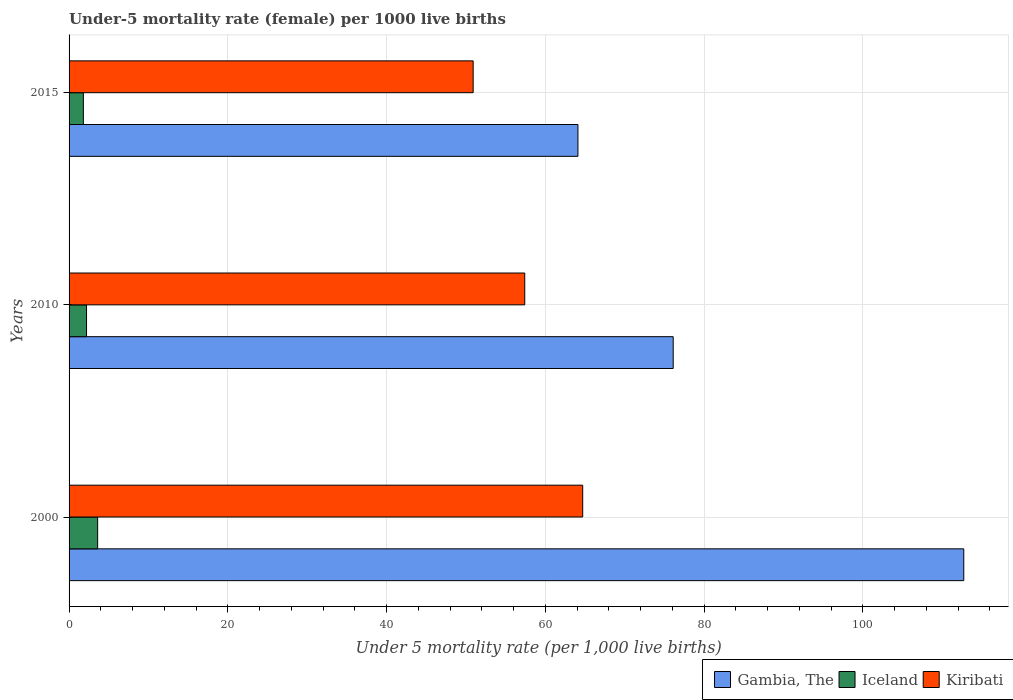How many different coloured bars are there?
Your response must be concise. 3. How many groups of bars are there?
Provide a short and direct response. 3. Are the number of bars on each tick of the Y-axis equal?
Ensure brevity in your answer.  Yes. How many bars are there on the 2nd tick from the top?
Offer a terse response. 3. In how many cases, is the number of bars for a given year not equal to the number of legend labels?
Keep it short and to the point. 0. What is the under-five mortality rate in Iceland in 2000?
Keep it short and to the point. 3.6. Across all years, what is the maximum under-five mortality rate in Kiribati?
Give a very brief answer. 64.7. Across all years, what is the minimum under-five mortality rate in Kiribati?
Provide a short and direct response. 50.9. In which year was the under-five mortality rate in Iceland minimum?
Your answer should be compact. 2015. What is the total under-five mortality rate in Gambia, The in the graph?
Provide a succinct answer. 252.9. What is the difference between the under-five mortality rate in Iceland in 2010 and the under-five mortality rate in Kiribati in 2000?
Provide a succinct answer. -62.5. What is the average under-five mortality rate in Gambia, The per year?
Make the answer very short. 84.3. In the year 2010, what is the difference between the under-five mortality rate in Iceland and under-five mortality rate in Kiribati?
Ensure brevity in your answer.  -55.2. What is the ratio of the under-five mortality rate in Kiribati in 2010 to that in 2015?
Offer a terse response. 1.13. What is the difference between the highest and the lowest under-five mortality rate in Iceland?
Give a very brief answer. 1.8. In how many years, is the under-five mortality rate in Iceland greater than the average under-five mortality rate in Iceland taken over all years?
Offer a terse response. 1. Is the sum of the under-five mortality rate in Kiribati in 2000 and 2010 greater than the maximum under-five mortality rate in Gambia, The across all years?
Ensure brevity in your answer.  Yes. What does the 2nd bar from the top in 2010 represents?
Provide a succinct answer. Iceland. What does the 3rd bar from the bottom in 2015 represents?
Provide a succinct answer. Kiribati. Are all the bars in the graph horizontal?
Give a very brief answer. Yes. Are the values on the major ticks of X-axis written in scientific E-notation?
Ensure brevity in your answer.  No. Does the graph contain any zero values?
Provide a short and direct response. No. Does the graph contain grids?
Provide a succinct answer. Yes. Where does the legend appear in the graph?
Make the answer very short. Bottom right. What is the title of the graph?
Your answer should be very brief. Under-5 mortality rate (female) per 1000 live births. What is the label or title of the X-axis?
Your answer should be compact. Under 5 mortality rate (per 1,0 live births). What is the Under 5 mortality rate (per 1,000 live births) of Gambia, The in 2000?
Ensure brevity in your answer.  112.7. What is the Under 5 mortality rate (per 1,000 live births) in Iceland in 2000?
Make the answer very short. 3.6. What is the Under 5 mortality rate (per 1,000 live births) in Kiribati in 2000?
Keep it short and to the point. 64.7. What is the Under 5 mortality rate (per 1,000 live births) in Gambia, The in 2010?
Keep it short and to the point. 76.1. What is the Under 5 mortality rate (per 1,000 live births) of Iceland in 2010?
Your answer should be compact. 2.2. What is the Under 5 mortality rate (per 1,000 live births) of Kiribati in 2010?
Make the answer very short. 57.4. What is the Under 5 mortality rate (per 1,000 live births) of Gambia, The in 2015?
Make the answer very short. 64.1. What is the Under 5 mortality rate (per 1,000 live births) in Iceland in 2015?
Make the answer very short. 1.8. What is the Under 5 mortality rate (per 1,000 live births) of Kiribati in 2015?
Your answer should be compact. 50.9. Across all years, what is the maximum Under 5 mortality rate (per 1,000 live births) in Gambia, The?
Offer a very short reply. 112.7. Across all years, what is the maximum Under 5 mortality rate (per 1,000 live births) in Kiribati?
Your answer should be compact. 64.7. Across all years, what is the minimum Under 5 mortality rate (per 1,000 live births) of Gambia, The?
Provide a short and direct response. 64.1. Across all years, what is the minimum Under 5 mortality rate (per 1,000 live births) of Iceland?
Offer a terse response. 1.8. Across all years, what is the minimum Under 5 mortality rate (per 1,000 live births) in Kiribati?
Ensure brevity in your answer.  50.9. What is the total Under 5 mortality rate (per 1,000 live births) of Gambia, The in the graph?
Your answer should be compact. 252.9. What is the total Under 5 mortality rate (per 1,000 live births) in Kiribati in the graph?
Provide a succinct answer. 173. What is the difference between the Under 5 mortality rate (per 1,000 live births) of Gambia, The in 2000 and that in 2010?
Offer a very short reply. 36.6. What is the difference between the Under 5 mortality rate (per 1,000 live births) in Kiribati in 2000 and that in 2010?
Your answer should be compact. 7.3. What is the difference between the Under 5 mortality rate (per 1,000 live births) of Gambia, The in 2000 and that in 2015?
Give a very brief answer. 48.6. What is the difference between the Under 5 mortality rate (per 1,000 live births) of Kiribati in 2000 and that in 2015?
Ensure brevity in your answer.  13.8. What is the difference between the Under 5 mortality rate (per 1,000 live births) of Gambia, The in 2000 and the Under 5 mortality rate (per 1,000 live births) of Iceland in 2010?
Provide a succinct answer. 110.5. What is the difference between the Under 5 mortality rate (per 1,000 live births) of Gambia, The in 2000 and the Under 5 mortality rate (per 1,000 live births) of Kiribati in 2010?
Provide a short and direct response. 55.3. What is the difference between the Under 5 mortality rate (per 1,000 live births) in Iceland in 2000 and the Under 5 mortality rate (per 1,000 live births) in Kiribati in 2010?
Offer a very short reply. -53.8. What is the difference between the Under 5 mortality rate (per 1,000 live births) in Gambia, The in 2000 and the Under 5 mortality rate (per 1,000 live births) in Iceland in 2015?
Provide a succinct answer. 110.9. What is the difference between the Under 5 mortality rate (per 1,000 live births) in Gambia, The in 2000 and the Under 5 mortality rate (per 1,000 live births) in Kiribati in 2015?
Your answer should be very brief. 61.8. What is the difference between the Under 5 mortality rate (per 1,000 live births) of Iceland in 2000 and the Under 5 mortality rate (per 1,000 live births) of Kiribati in 2015?
Make the answer very short. -47.3. What is the difference between the Under 5 mortality rate (per 1,000 live births) in Gambia, The in 2010 and the Under 5 mortality rate (per 1,000 live births) in Iceland in 2015?
Keep it short and to the point. 74.3. What is the difference between the Under 5 mortality rate (per 1,000 live births) of Gambia, The in 2010 and the Under 5 mortality rate (per 1,000 live births) of Kiribati in 2015?
Your answer should be compact. 25.2. What is the difference between the Under 5 mortality rate (per 1,000 live births) of Iceland in 2010 and the Under 5 mortality rate (per 1,000 live births) of Kiribati in 2015?
Your response must be concise. -48.7. What is the average Under 5 mortality rate (per 1,000 live births) in Gambia, The per year?
Ensure brevity in your answer.  84.3. What is the average Under 5 mortality rate (per 1,000 live births) in Iceland per year?
Offer a terse response. 2.53. What is the average Under 5 mortality rate (per 1,000 live births) in Kiribati per year?
Give a very brief answer. 57.67. In the year 2000, what is the difference between the Under 5 mortality rate (per 1,000 live births) of Gambia, The and Under 5 mortality rate (per 1,000 live births) of Iceland?
Your response must be concise. 109.1. In the year 2000, what is the difference between the Under 5 mortality rate (per 1,000 live births) of Iceland and Under 5 mortality rate (per 1,000 live births) of Kiribati?
Provide a short and direct response. -61.1. In the year 2010, what is the difference between the Under 5 mortality rate (per 1,000 live births) in Gambia, The and Under 5 mortality rate (per 1,000 live births) in Iceland?
Your response must be concise. 73.9. In the year 2010, what is the difference between the Under 5 mortality rate (per 1,000 live births) in Gambia, The and Under 5 mortality rate (per 1,000 live births) in Kiribati?
Provide a short and direct response. 18.7. In the year 2010, what is the difference between the Under 5 mortality rate (per 1,000 live births) of Iceland and Under 5 mortality rate (per 1,000 live births) of Kiribati?
Your answer should be compact. -55.2. In the year 2015, what is the difference between the Under 5 mortality rate (per 1,000 live births) in Gambia, The and Under 5 mortality rate (per 1,000 live births) in Iceland?
Keep it short and to the point. 62.3. In the year 2015, what is the difference between the Under 5 mortality rate (per 1,000 live births) in Iceland and Under 5 mortality rate (per 1,000 live births) in Kiribati?
Your response must be concise. -49.1. What is the ratio of the Under 5 mortality rate (per 1,000 live births) of Gambia, The in 2000 to that in 2010?
Keep it short and to the point. 1.48. What is the ratio of the Under 5 mortality rate (per 1,000 live births) in Iceland in 2000 to that in 2010?
Your answer should be compact. 1.64. What is the ratio of the Under 5 mortality rate (per 1,000 live births) of Kiribati in 2000 to that in 2010?
Provide a short and direct response. 1.13. What is the ratio of the Under 5 mortality rate (per 1,000 live births) of Gambia, The in 2000 to that in 2015?
Keep it short and to the point. 1.76. What is the ratio of the Under 5 mortality rate (per 1,000 live births) in Kiribati in 2000 to that in 2015?
Your answer should be compact. 1.27. What is the ratio of the Under 5 mortality rate (per 1,000 live births) in Gambia, The in 2010 to that in 2015?
Offer a terse response. 1.19. What is the ratio of the Under 5 mortality rate (per 1,000 live births) in Iceland in 2010 to that in 2015?
Provide a succinct answer. 1.22. What is the ratio of the Under 5 mortality rate (per 1,000 live births) of Kiribati in 2010 to that in 2015?
Give a very brief answer. 1.13. What is the difference between the highest and the second highest Under 5 mortality rate (per 1,000 live births) of Gambia, The?
Offer a very short reply. 36.6. What is the difference between the highest and the second highest Under 5 mortality rate (per 1,000 live births) of Iceland?
Your answer should be very brief. 1.4. What is the difference between the highest and the second highest Under 5 mortality rate (per 1,000 live births) of Kiribati?
Your response must be concise. 7.3. What is the difference between the highest and the lowest Under 5 mortality rate (per 1,000 live births) of Gambia, The?
Provide a short and direct response. 48.6. What is the difference between the highest and the lowest Under 5 mortality rate (per 1,000 live births) of Iceland?
Provide a succinct answer. 1.8. What is the difference between the highest and the lowest Under 5 mortality rate (per 1,000 live births) in Kiribati?
Offer a very short reply. 13.8. 